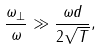Convert formula to latex. <formula><loc_0><loc_0><loc_500><loc_500>\frac { \omega _ { \perp } } { \omega _ { \| } } \gg \frac { \omega _ { \| } d } { 2 \sqrt { T } } ,</formula> 